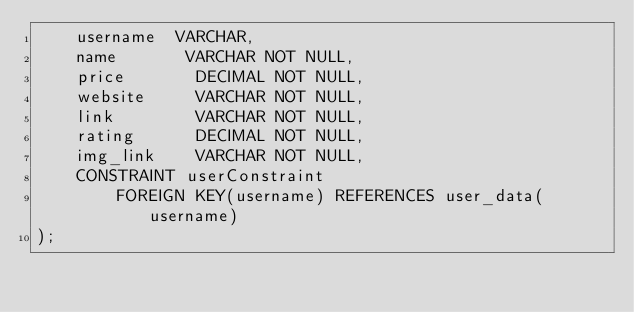Convert code to text. <code><loc_0><loc_0><loc_500><loc_500><_SQL_>    username  VARCHAR,
    name       VARCHAR NOT NULL,
    price       DECIMAL NOT NULL,
    website     VARCHAR NOT NULL,
    link        VARCHAR NOT NULL,
    rating      DECIMAL NOT NULL,
    img_link    VARCHAR NOT NULL,
    CONSTRAINT userConstraint
        FOREIGN KEY(username) REFERENCES user_data(username)
);

</code> 